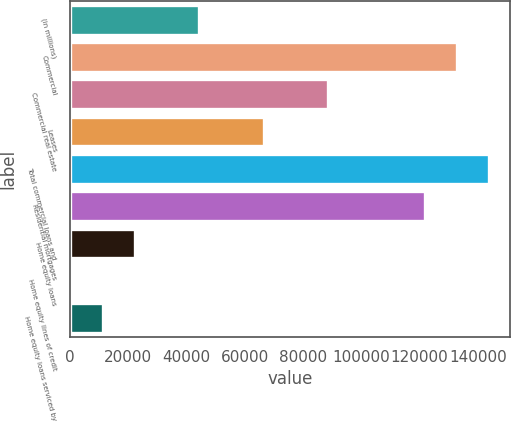Convert chart to OTSL. <chart><loc_0><loc_0><loc_500><loc_500><bar_chart><fcel>(in millions)<fcel>Commercial<fcel>Commercial real estate<fcel>Leases<fcel>Total commercial loans and<fcel>Residential mortgages<fcel>Home equity loans<fcel>Home equity lines of credit<fcel>Home equity loans serviced by<nl><fcel>44336.2<fcel>132711<fcel>88523.4<fcel>66429.8<fcel>143757<fcel>121664<fcel>22242.6<fcel>149<fcel>11195.8<nl></chart> 